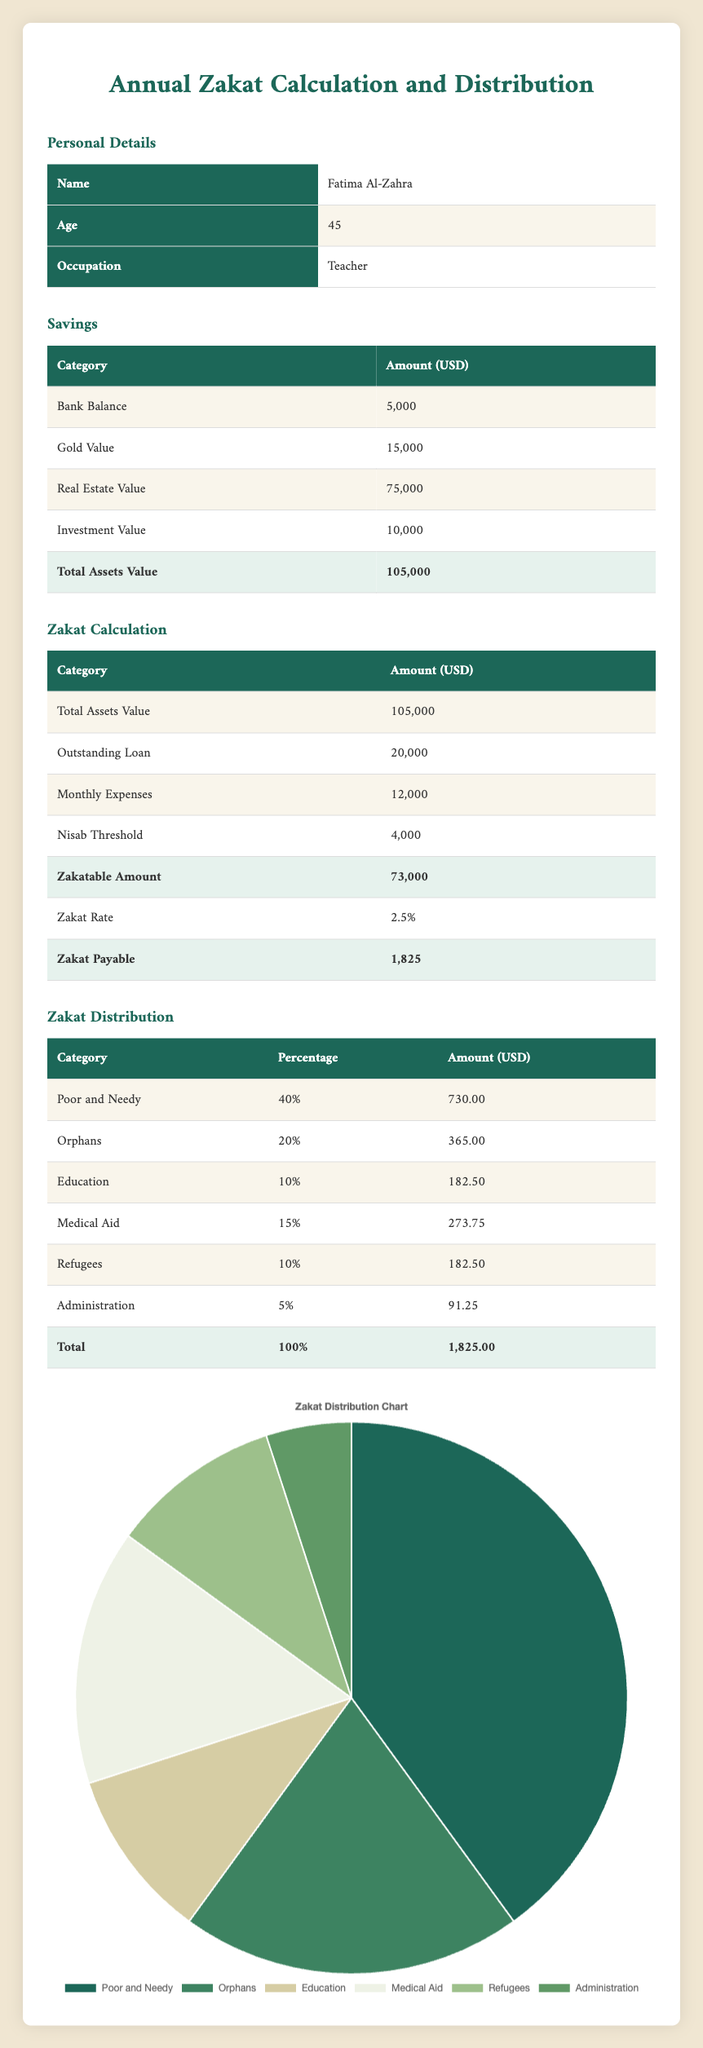What is the total amount of Zakat payable? The total amount of Zakat payable is listed directly in the Zakat Calculation section of the table, which states it is 1,825 USD.
Answer: 1,825 What percentage of the total Zakat distribution is allocated to Medical Aid? According to the Zakat Distribution section, Medical Aid is allocated 15% of the total Zakat distribution.
Answer: 15% Is the Zakatable amount higher than the Nisab threshold? The Zakatable amount is given as 73,000 USD, while the Nisab threshold is 4,000 USD. Since 73,000 is greater than 4,000, it confirms that the Zakatable amount is higher.
Answer: Yes How much money is allocated to Education in the Zakat Distribution? In the Zakat Distribution section, the amount allocated to Education is explicitly stated as 182.50 USD.
Answer: 182.50 What is the total value of Fatima's Real Estate and Gold combined? To find the total value of Real Estate and Gold, we sum their values: 15,000 (Gold) + 75,000 (Real Estate) = 90,000 USD.
Answer: 90,000 How much more is allocated to Poor and Needy compared to Refugees? Poor and Needy receive 730.00 USD and Refugees receive 182.50 USD. The difference is calculated as 730.00 - 182.50 = 547.50 USD.
Answer: 547.50 What fraction of the Zakat payable is given to Orphans? Zakat payable is 1,825.00, and the amount allocated to Orphans is 365.00. To find the fraction, we calculate 365.00 / 1,825.00, which simplifies to 1/5 or 0.20.
Answer: 0.20 What is the total percentage of Zakat allocated to categories other than Poor and Needy? The total percentage for categories other than Poor and Needy is calculated as follows: 20% (Orphans) + 10% (Education) + 15% (Medical Aid) + 10% (Refugees) + 5% (Administration) = 70%.
Answer: 70% How much does Fatima have in total savings investment? The total savings investment includes Bank Balance (5,000), Gold Value (15,000), Real Estate Value (75,000), and Investment Value (10,000), which adds up to 105,000 USD in total savings investment.
Answer: 105,000 